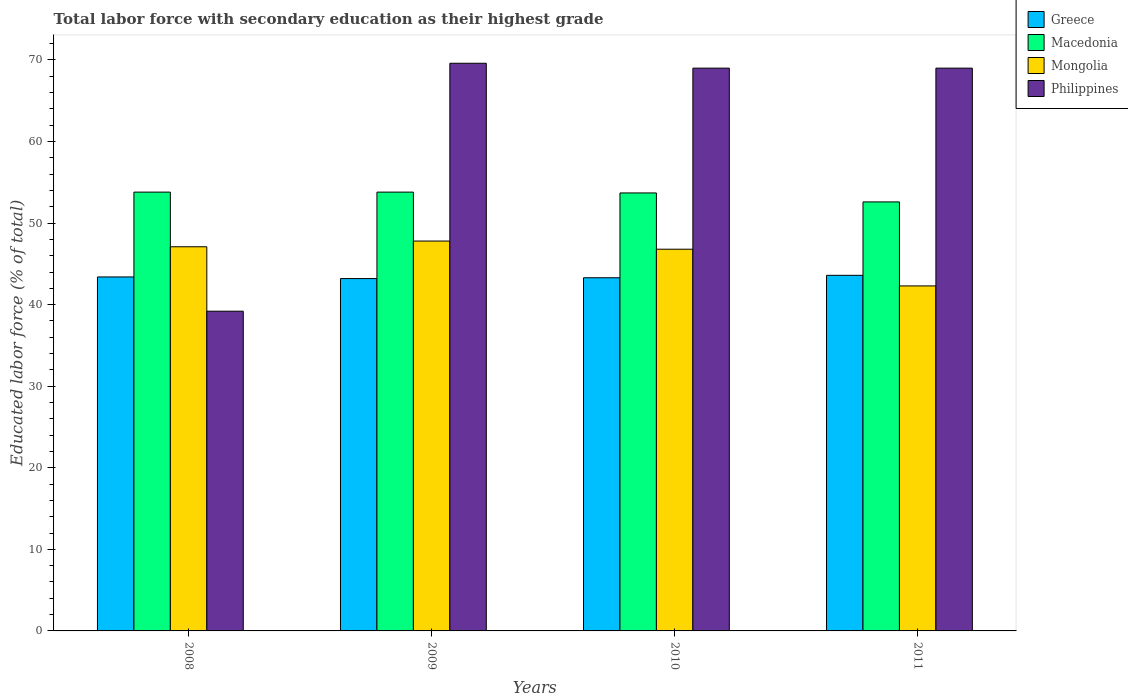How many groups of bars are there?
Your response must be concise. 4. Are the number of bars per tick equal to the number of legend labels?
Your answer should be compact. Yes. How many bars are there on the 4th tick from the left?
Ensure brevity in your answer.  4. How many bars are there on the 2nd tick from the right?
Give a very brief answer. 4. What is the label of the 2nd group of bars from the left?
Provide a succinct answer. 2009. In how many cases, is the number of bars for a given year not equal to the number of legend labels?
Give a very brief answer. 0. What is the percentage of total labor force with primary education in Mongolia in 2008?
Ensure brevity in your answer.  47.1. Across all years, what is the maximum percentage of total labor force with primary education in Philippines?
Make the answer very short. 69.6. Across all years, what is the minimum percentage of total labor force with primary education in Mongolia?
Give a very brief answer. 42.3. In which year was the percentage of total labor force with primary education in Philippines maximum?
Keep it short and to the point. 2009. In which year was the percentage of total labor force with primary education in Macedonia minimum?
Your response must be concise. 2011. What is the total percentage of total labor force with primary education in Greece in the graph?
Provide a short and direct response. 173.5. What is the difference between the percentage of total labor force with primary education in Mongolia in 2008 and that in 2009?
Provide a short and direct response. -0.7. What is the difference between the percentage of total labor force with primary education in Macedonia in 2008 and the percentage of total labor force with primary education in Greece in 2009?
Ensure brevity in your answer.  10.6. What is the average percentage of total labor force with primary education in Greece per year?
Offer a terse response. 43.38. In the year 2009, what is the difference between the percentage of total labor force with primary education in Greece and percentage of total labor force with primary education in Mongolia?
Offer a very short reply. -4.6. What is the ratio of the percentage of total labor force with primary education in Greece in 2009 to that in 2011?
Your answer should be compact. 0.99. What is the difference between the highest and the second highest percentage of total labor force with primary education in Macedonia?
Your answer should be very brief. 0. What is the difference between the highest and the lowest percentage of total labor force with primary education in Greece?
Make the answer very short. 0.4. Is the sum of the percentage of total labor force with primary education in Macedonia in 2010 and 2011 greater than the maximum percentage of total labor force with primary education in Mongolia across all years?
Offer a very short reply. Yes. What does the 2nd bar from the left in 2010 represents?
Ensure brevity in your answer.  Macedonia. What does the 3rd bar from the right in 2010 represents?
Your answer should be compact. Macedonia. How many bars are there?
Your answer should be compact. 16. How many years are there in the graph?
Your response must be concise. 4. Does the graph contain grids?
Keep it short and to the point. No. Where does the legend appear in the graph?
Your response must be concise. Top right. How many legend labels are there?
Offer a terse response. 4. How are the legend labels stacked?
Make the answer very short. Vertical. What is the title of the graph?
Keep it short and to the point. Total labor force with secondary education as their highest grade. What is the label or title of the X-axis?
Keep it short and to the point. Years. What is the label or title of the Y-axis?
Make the answer very short. Educated labor force (% of total). What is the Educated labor force (% of total) in Greece in 2008?
Provide a succinct answer. 43.4. What is the Educated labor force (% of total) of Macedonia in 2008?
Offer a very short reply. 53.8. What is the Educated labor force (% of total) in Mongolia in 2008?
Give a very brief answer. 47.1. What is the Educated labor force (% of total) in Philippines in 2008?
Provide a short and direct response. 39.2. What is the Educated labor force (% of total) in Greece in 2009?
Make the answer very short. 43.2. What is the Educated labor force (% of total) of Macedonia in 2009?
Offer a terse response. 53.8. What is the Educated labor force (% of total) of Mongolia in 2009?
Give a very brief answer. 47.8. What is the Educated labor force (% of total) in Philippines in 2009?
Your response must be concise. 69.6. What is the Educated labor force (% of total) of Greece in 2010?
Make the answer very short. 43.3. What is the Educated labor force (% of total) of Macedonia in 2010?
Your answer should be compact. 53.7. What is the Educated labor force (% of total) in Mongolia in 2010?
Give a very brief answer. 46.8. What is the Educated labor force (% of total) of Greece in 2011?
Provide a succinct answer. 43.6. What is the Educated labor force (% of total) in Macedonia in 2011?
Ensure brevity in your answer.  52.6. What is the Educated labor force (% of total) of Mongolia in 2011?
Offer a very short reply. 42.3. What is the Educated labor force (% of total) in Philippines in 2011?
Provide a short and direct response. 69. Across all years, what is the maximum Educated labor force (% of total) of Greece?
Keep it short and to the point. 43.6. Across all years, what is the maximum Educated labor force (% of total) of Macedonia?
Your answer should be compact. 53.8. Across all years, what is the maximum Educated labor force (% of total) of Mongolia?
Your answer should be very brief. 47.8. Across all years, what is the maximum Educated labor force (% of total) of Philippines?
Provide a short and direct response. 69.6. Across all years, what is the minimum Educated labor force (% of total) in Greece?
Offer a very short reply. 43.2. Across all years, what is the minimum Educated labor force (% of total) in Macedonia?
Keep it short and to the point. 52.6. Across all years, what is the minimum Educated labor force (% of total) of Mongolia?
Provide a succinct answer. 42.3. Across all years, what is the minimum Educated labor force (% of total) in Philippines?
Provide a short and direct response. 39.2. What is the total Educated labor force (% of total) in Greece in the graph?
Give a very brief answer. 173.5. What is the total Educated labor force (% of total) in Macedonia in the graph?
Your response must be concise. 213.9. What is the total Educated labor force (% of total) of Mongolia in the graph?
Ensure brevity in your answer.  184. What is the total Educated labor force (% of total) in Philippines in the graph?
Ensure brevity in your answer.  246.8. What is the difference between the Educated labor force (% of total) in Philippines in 2008 and that in 2009?
Give a very brief answer. -30.4. What is the difference between the Educated labor force (% of total) of Mongolia in 2008 and that in 2010?
Provide a short and direct response. 0.3. What is the difference between the Educated labor force (% of total) of Philippines in 2008 and that in 2010?
Your response must be concise. -29.8. What is the difference between the Educated labor force (% of total) of Macedonia in 2008 and that in 2011?
Provide a succinct answer. 1.2. What is the difference between the Educated labor force (% of total) in Philippines in 2008 and that in 2011?
Offer a terse response. -29.8. What is the difference between the Educated labor force (% of total) of Greece in 2009 and that in 2010?
Your answer should be compact. -0.1. What is the difference between the Educated labor force (% of total) in Mongolia in 2009 and that in 2011?
Your response must be concise. 5.5. What is the difference between the Educated labor force (% of total) in Macedonia in 2010 and that in 2011?
Offer a terse response. 1.1. What is the difference between the Educated labor force (% of total) in Greece in 2008 and the Educated labor force (% of total) in Macedonia in 2009?
Offer a terse response. -10.4. What is the difference between the Educated labor force (% of total) of Greece in 2008 and the Educated labor force (% of total) of Mongolia in 2009?
Make the answer very short. -4.4. What is the difference between the Educated labor force (% of total) of Greece in 2008 and the Educated labor force (% of total) of Philippines in 2009?
Your response must be concise. -26.2. What is the difference between the Educated labor force (% of total) of Macedonia in 2008 and the Educated labor force (% of total) of Philippines in 2009?
Offer a terse response. -15.8. What is the difference between the Educated labor force (% of total) in Mongolia in 2008 and the Educated labor force (% of total) in Philippines in 2009?
Offer a very short reply. -22.5. What is the difference between the Educated labor force (% of total) in Greece in 2008 and the Educated labor force (% of total) in Macedonia in 2010?
Your answer should be very brief. -10.3. What is the difference between the Educated labor force (% of total) of Greece in 2008 and the Educated labor force (% of total) of Philippines in 2010?
Offer a terse response. -25.6. What is the difference between the Educated labor force (% of total) of Macedonia in 2008 and the Educated labor force (% of total) of Mongolia in 2010?
Give a very brief answer. 7. What is the difference between the Educated labor force (% of total) of Macedonia in 2008 and the Educated labor force (% of total) of Philippines in 2010?
Provide a succinct answer. -15.2. What is the difference between the Educated labor force (% of total) in Mongolia in 2008 and the Educated labor force (% of total) in Philippines in 2010?
Offer a terse response. -21.9. What is the difference between the Educated labor force (% of total) of Greece in 2008 and the Educated labor force (% of total) of Mongolia in 2011?
Ensure brevity in your answer.  1.1. What is the difference between the Educated labor force (% of total) of Greece in 2008 and the Educated labor force (% of total) of Philippines in 2011?
Your answer should be compact. -25.6. What is the difference between the Educated labor force (% of total) of Macedonia in 2008 and the Educated labor force (% of total) of Mongolia in 2011?
Offer a very short reply. 11.5. What is the difference between the Educated labor force (% of total) in Macedonia in 2008 and the Educated labor force (% of total) in Philippines in 2011?
Make the answer very short. -15.2. What is the difference between the Educated labor force (% of total) of Mongolia in 2008 and the Educated labor force (% of total) of Philippines in 2011?
Your answer should be compact. -21.9. What is the difference between the Educated labor force (% of total) in Greece in 2009 and the Educated labor force (% of total) in Philippines in 2010?
Your response must be concise. -25.8. What is the difference between the Educated labor force (% of total) of Macedonia in 2009 and the Educated labor force (% of total) of Philippines in 2010?
Your response must be concise. -15.2. What is the difference between the Educated labor force (% of total) in Mongolia in 2009 and the Educated labor force (% of total) in Philippines in 2010?
Offer a very short reply. -21.2. What is the difference between the Educated labor force (% of total) in Greece in 2009 and the Educated labor force (% of total) in Philippines in 2011?
Offer a very short reply. -25.8. What is the difference between the Educated labor force (% of total) in Macedonia in 2009 and the Educated labor force (% of total) in Mongolia in 2011?
Ensure brevity in your answer.  11.5. What is the difference between the Educated labor force (% of total) in Macedonia in 2009 and the Educated labor force (% of total) in Philippines in 2011?
Provide a short and direct response. -15.2. What is the difference between the Educated labor force (% of total) of Mongolia in 2009 and the Educated labor force (% of total) of Philippines in 2011?
Your response must be concise. -21.2. What is the difference between the Educated labor force (% of total) of Greece in 2010 and the Educated labor force (% of total) of Philippines in 2011?
Your answer should be very brief. -25.7. What is the difference between the Educated labor force (% of total) in Macedonia in 2010 and the Educated labor force (% of total) in Mongolia in 2011?
Provide a short and direct response. 11.4. What is the difference between the Educated labor force (% of total) of Macedonia in 2010 and the Educated labor force (% of total) of Philippines in 2011?
Offer a terse response. -15.3. What is the difference between the Educated labor force (% of total) in Mongolia in 2010 and the Educated labor force (% of total) in Philippines in 2011?
Offer a terse response. -22.2. What is the average Educated labor force (% of total) in Greece per year?
Your answer should be compact. 43.38. What is the average Educated labor force (% of total) in Macedonia per year?
Keep it short and to the point. 53.48. What is the average Educated labor force (% of total) of Philippines per year?
Make the answer very short. 61.7. In the year 2008, what is the difference between the Educated labor force (% of total) in Greece and Educated labor force (% of total) in Philippines?
Provide a succinct answer. 4.2. In the year 2008, what is the difference between the Educated labor force (% of total) of Mongolia and Educated labor force (% of total) of Philippines?
Provide a succinct answer. 7.9. In the year 2009, what is the difference between the Educated labor force (% of total) in Greece and Educated labor force (% of total) in Philippines?
Ensure brevity in your answer.  -26.4. In the year 2009, what is the difference between the Educated labor force (% of total) in Macedonia and Educated labor force (% of total) in Mongolia?
Your response must be concise. 6. In the year 2009, what is the difference between the Educated labor force (% of total) of Macedonia and Educated labor force (% of total) of Philippines?
Your response must be concise. -15.8. In the year 2009, what is the difference between the Educated labor force (% of total) of Mongolia and Educated labor force (% of total) of Philippines?
Make the answer very short. -21.8. In the year 2010, what is the difference between the Educated labor force (% of total) of Greece and Educated labor force (% of total) of Macedonia?
Give a very brief answer. -10.4. In the year 2010, what is the difference between the Educated labor force (% of total) of Greece and Educated labor force (% of total) of Mongolia?
Your answer should be compact. -3.5. In the year 2010, what is the difference between the Educated labor force (% of total) of Greece and Educated labor force (% of total) of Philippines?
Ensure brevity in your answer.  -25.7. In the year 2010, what is the difference between the Educated labor force (% of total) in Macedonia and Educated labor force (% of total) in Mongolia?
Provide a succinct answer. 6.9. In the year 2010, what is the difference between the Educated labor force (% of total) of Macedonia and Educated labor force (% of total) of Philippines?
Your response must be concise. -15.3. In the year 2010, what is the difference between the Educated labor force (% of total) in Mongolia and Educated labor force (% of total) in Philippines?
Your answer should be very brief. -22.2. In the year 2011, what is the difference between the Educated labor force (% of total) in Greece and Educated labor force (% of total) in Macedonia?
Give a very brief answer. -9. In the year 2011, what is the difference between the Educated labor force (% of total) in Greece and Educated labor force (% of total) in Mongolia?
Make the answer very short. 1.3. In the year 2011, what is the difference between the Educated labor force (% of total) in Greece and Educated labor force (% of total) in Philippines?
Provide a short and direct response. -25.4. In the year 2011, what is the difference between the Educated labor force (% of total) in Macedonia and Educated labor force (% of total) in Philippines?
Your answer should be compact. -16.4. In the year 2011, what is the difference between the Educated labor force (% of total) in Mongolia and Educated labor force (% of total) in Philippines?
Offer a very short reply. -26.7. What is the ratio of the Educated labor force (% of total) of Greece in 2008 to that in 2009?
Keep it short and to the point. 1. What is the ratio of the Educated labor force (% of total) of Macedonia in 2008 to that in 2009?
Your response must be concise. 1. What is the ratio of the Educated labor force (% of total) of Mongolia in 2008 to that in 2009?
Offer a terse response. 0.99. What is the ratio of the Educated labor force (% of total) in Philippines in 2008 to that in 2009?
Your response must be concise. 0.56. What is the ratio of the Educated labor force (% of total) in Mongolia in 2008 to that in 2010?
Make the answer very short. 1.01. What is the ratio of the Educated labor force (% of total) of Philippines in 2008 to that in 2010?
Make the answer very short. 0.57. What is the ratio of the Educated labor force (% of total) of Greece in 2008 to that in 2011?
Offer a terse response. 1. What is the ratio of the Educated labor force (% of total) of Macedonia in 2008 to that in 2011?
Give a very brief answer. 1.02. What is the ratio of the Educated labor force (% of total) in Mongolia in 2008 to that in 2011?
Provide a succinct answer. 1.11. What is the ratio of the Educated labor force (% of total) in Philippines in 2008 to that in 2011?
Your answer should be compact. 0.57. What is the ratio of the Educated labor force (% of total) in Macedonia in 2009 to that in 2010?
Offer a very short reply. 1. What is the ratio of the Educated labor force (% of total) in Mongolia in 2009 to that in 2010?
Provide a succinct answer. 1.02. What is the ratio of the Educated labor force (% of total) of Philippines in 2009 to that in 2010?
Keep it short and to the point. 1.01. What is the ratio of the Educated labor force (% of total) of Greece in 2009 to that in 2011?
Ensure brevity in your answer.  0.99. What is the ratio of the Educated labor force (% of total) of Macedonia in 2009 to that in 2011?
Provide a succinct answer. 1.02. What is the ratio of the Educated labor force (% of total) of Mongolia in 2009 to that in 2011?
Offer a very short reply. 1.13. What is the ratio of the Educated labor force (% of total) of Philippines in 2009 to that in 2011?
Provide a short and direct response. 1.01. What is the ratio of the Educated labor force (% of total) in Greece in 2010 to that in 2011?
Offer a very short reply. 0.99. What is the ratio of the Educated labor force (% of total) of Macedonia in 2010 to that in 2011?
Offer a terse response. 1.02. What is the ratio of the Educated labor force (% of total) of Mongolia in 2010 to that in 2011?
Make the answer very short. 1.11. What is the ratio of the Educated labor force (% of total) in Philippines in 2010 to that in 2011?
Provide a succinct answer. 1. What is the difference between the highest and the second highest Educated labor force (% of total) in Macedonia?
Provide a short and direct response. 0. What is the difference between the highest and the lowest Educated labor force (% of total) in Philippines?
Keep it short and to the point. 30.4. 